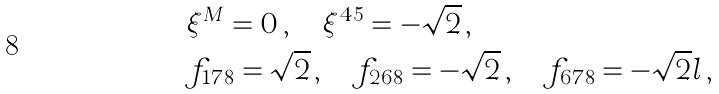<formula> <loc_0><loc_0><loc_500><loc_500>& \xi ^ { M } = 0 \, , \quad \xi ^ { 4 5 } = - \sqrt { 2 } \, , \\ & f _ { 1 7 8 } = \sqrt { 2 } \, , \quad f _ { 2 6 8 } = - \sqrt { 2 } \, , \quad f _ { 6 7 8 } = - \sqrt { 2 } l \, ,</formula> 